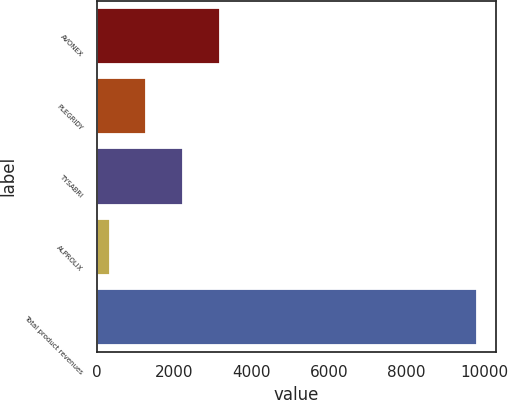<chart> <loc_0><loc_0><loc_500><loc_500><bar_chart><fcel>AVONEX<fcel>PLEGRIDY<fcel>TYSABRI<fcel>ALPROLIX<fcel>Total product revenues<nl><fcel>3178.96<fcel>1282.12<fcel>2230.54<fcel>333.7<fcel>9817.9<nl></chart> 